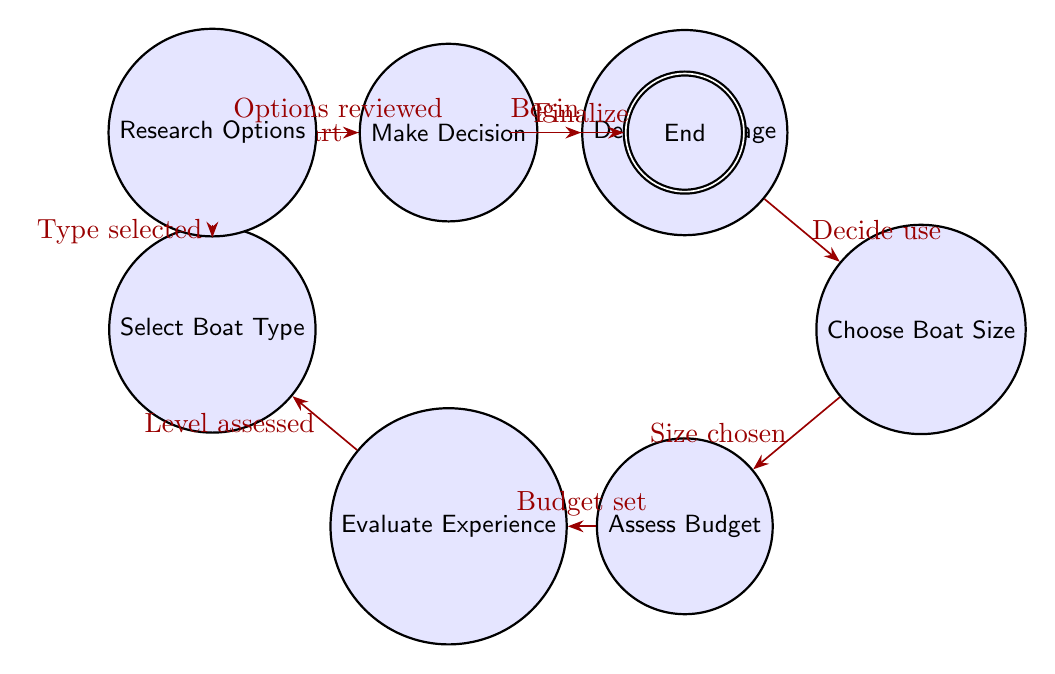What's the initial state in the diagram? The initial state is represented by the node labeled "Start." It is the first point in the decision process where the sailor begins making choices.
Answer: Start How many nodes are present in the diagram? Counting all the distinct states listed in the diagram, there are a total of 8 nodes: Start, Determine Usage, Choose Boat Size, Assess Budget, Evaluate Experience, Select Boat Type, Research Options, Make Decision, and End.
Answer: 8 What follows after "Assess Budget" in the decision process? The transition from "Assess Budget" leads to the next state, which is "Evaluate Experience." This indicates that after determining the budget, the sailor should evaluate their sailing experience level.
Answer: Evaluate Experience What is the last state in the process? The final state where the decision-making process concludes is labeled "End." This indicates that the sailor has completed their decision process and finalized their purchase decision.
Answer: End What state comes before "Select Boat Type"? The state immediately preceding "Select Boat Type" is "Evaluate Experience." This indicates that the evaluation of experience must be completed prior to selecting the type of sailing boat.
Answer: Evaluate Experience How many transitions are there from the "Choose Boat Size" state? There is one transition leading from the "Choose Boat Size" state to the "Assess Budget" state. This shows that after choosing the size, the next step is to assess the budget.
Answer: 1 What type of sailing boat is selected after assessing experience? After evaluating experience, the next step is selecting the type of sailing boat, which is referred to in the node labeled "Select Boat Type." It’s inferred that this state involves specifying the type based on prior assessments.
Answer: Select Boat Type Which nodes assume a linear relationship in the decision process? The nodes that follow a linear relationship are: Start -> Determine Usage -> Choose Boat Size -> Assess Budget -> Evaluate Experience -> Select Boat Type -> Research Options -> Make Decision -> End. This signifies a sequential decision-making flow without branching at these stages.
Answer: All nodes in sequence 